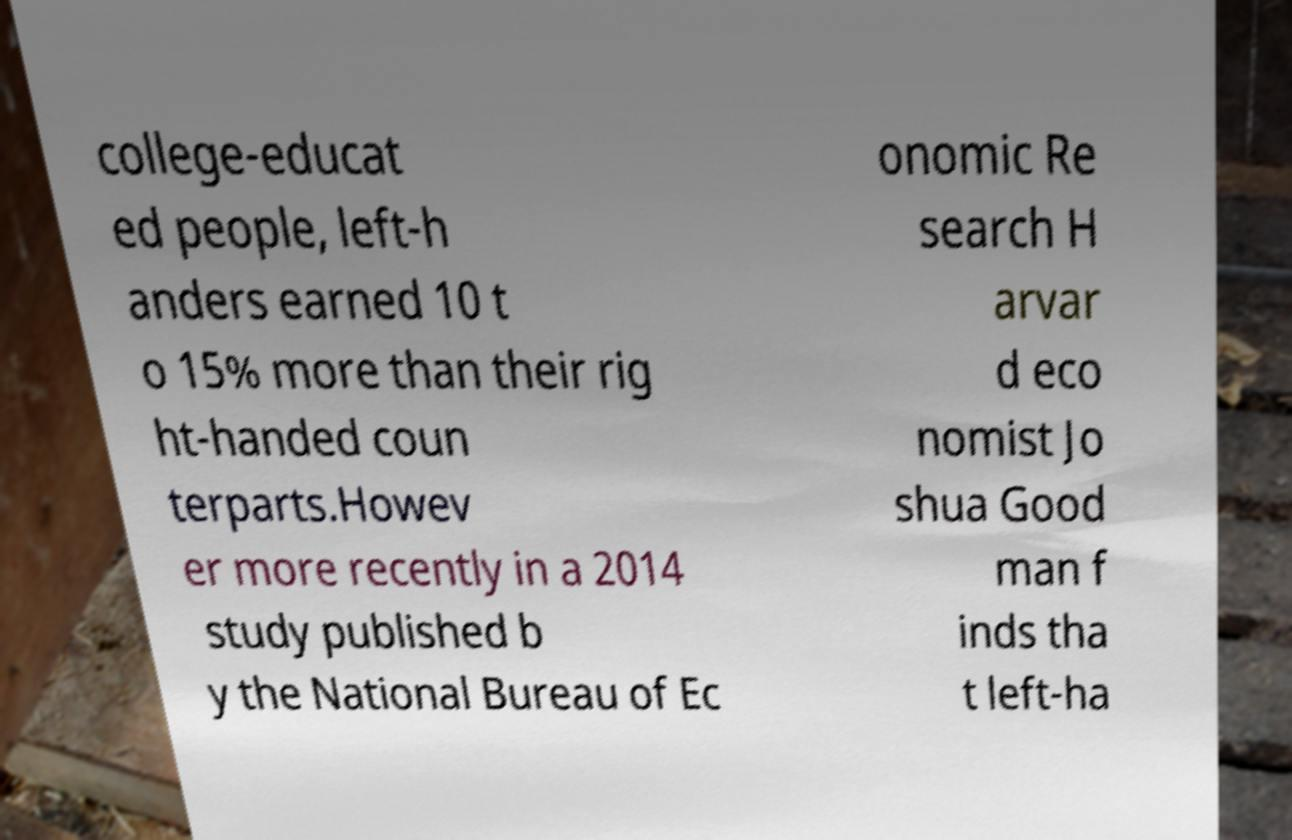Could you assist in decoding the text presented in this image and type it out clearly? college-educat ed people, left-h anders earned 10 t o 15% more than their rig ht-handed coun terparts.Howev er more recently in a 2014 study published b y the National Bureau of Ec onomic Re search H arvar d eco nomist Jo shua Good man f inds tha t left-ha 